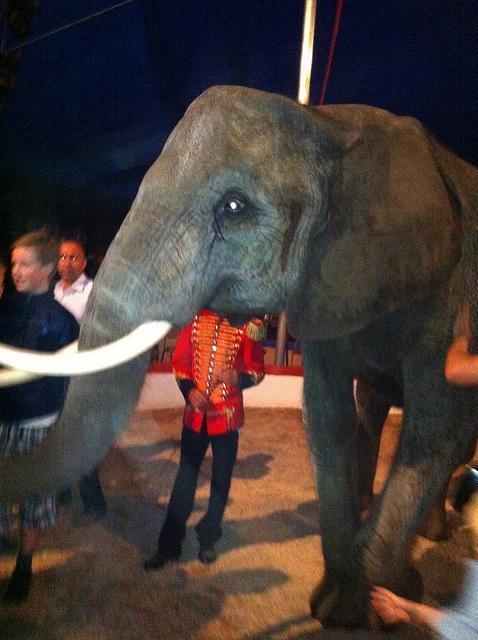How many elephant eyes can been seen?
Give a very brief answer. 1. How many people are there?
Give a very brief answer. 4. 